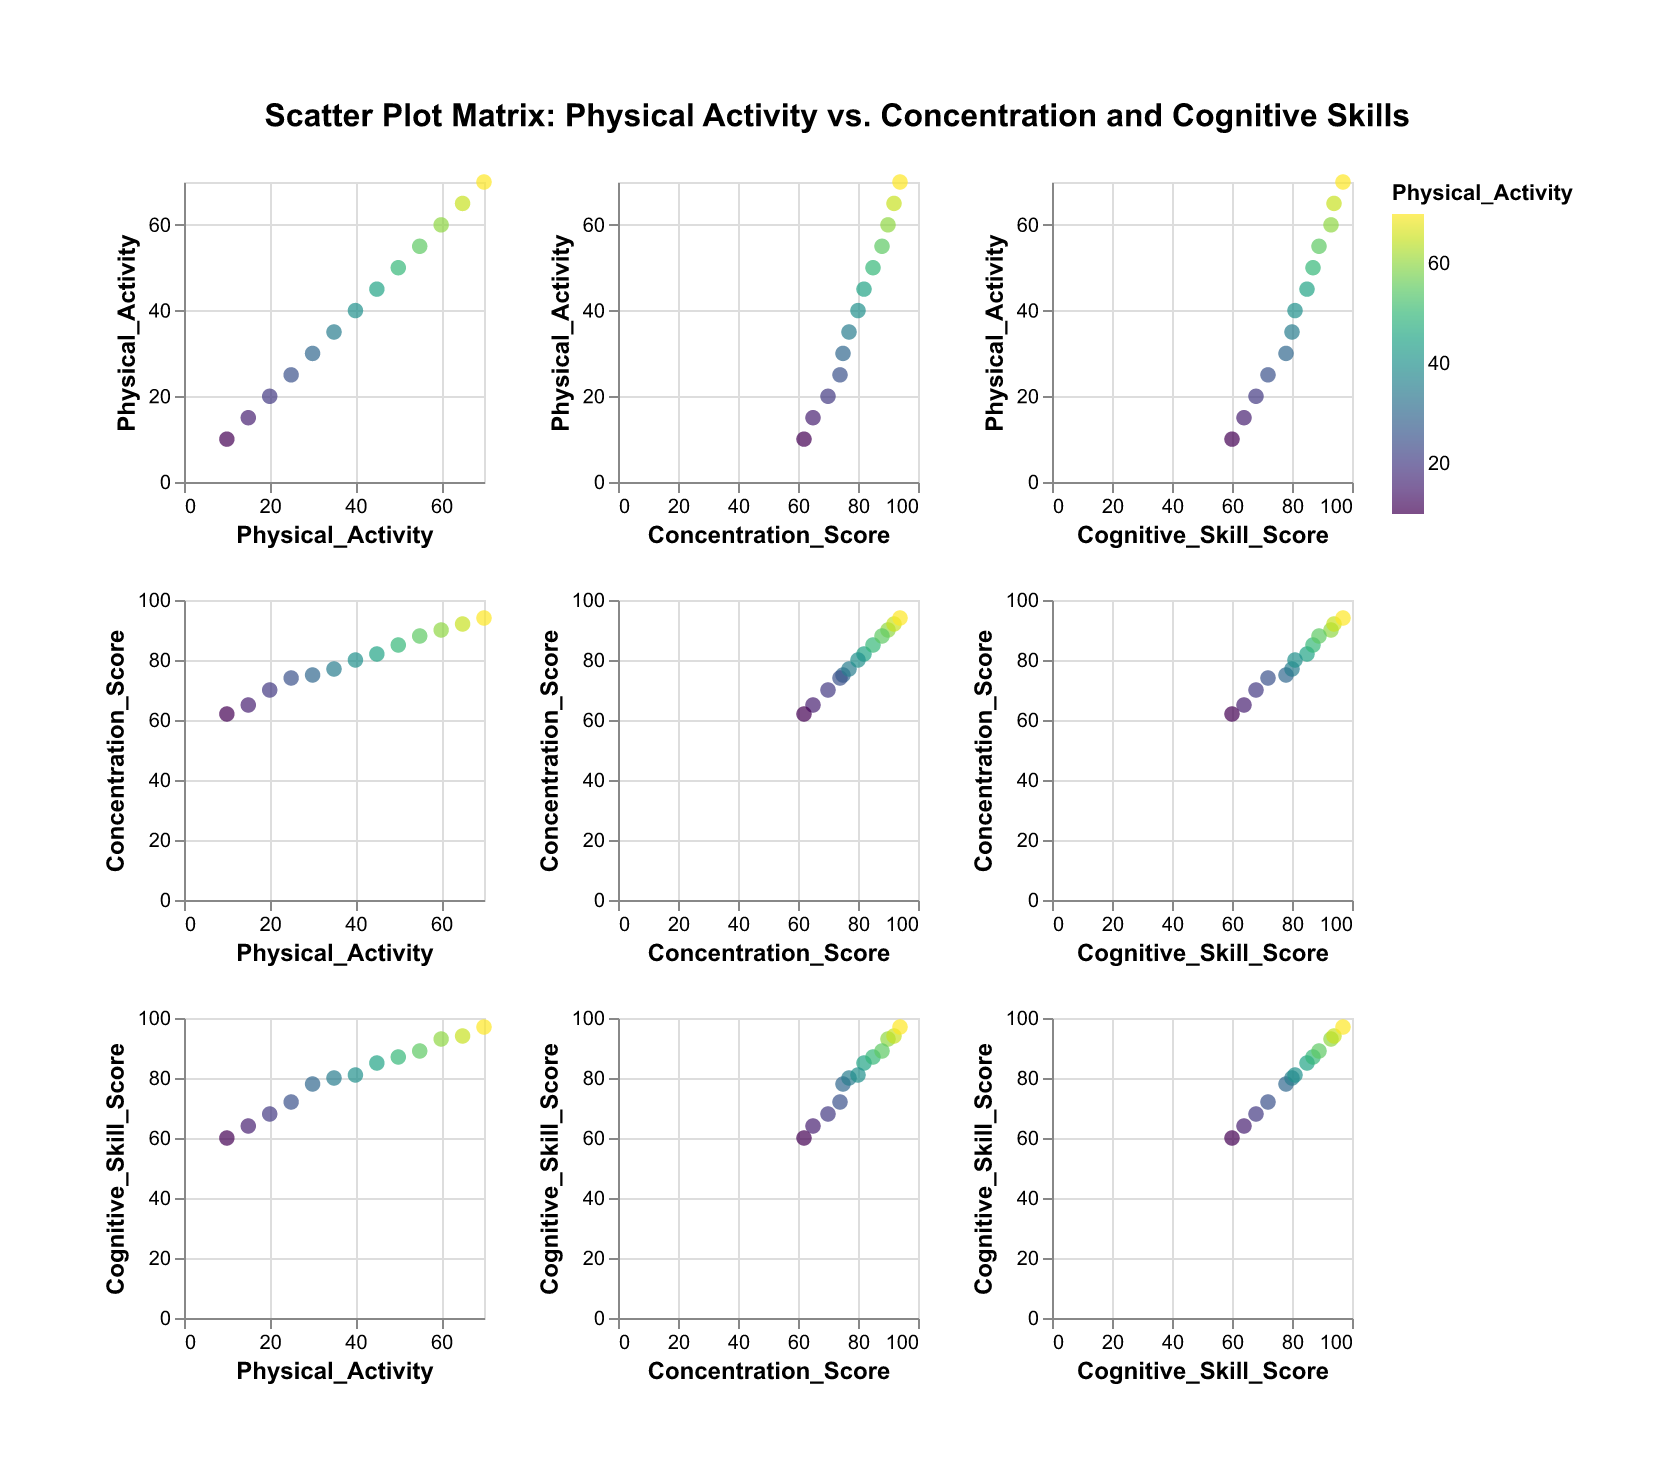What is the title of the scatter plot matrix? The title can be found at the top of the figure, usually indicating what the plot matrix is about. Here it is clearly stated.
Answer: Scatter Plot Matrix: Physical Activity vs. Concentration and Cognitive Skills How many data points are in the plot? Count the number of unique points on any of the scatter plots in the matrix. There are consistently 13 points across the plots.
Answer: 13 Which variable uses the color scheme? The color scheme is used to represent the 'Physical Activity' variable, as indicated in the legend inside the color scale.
Answer: Physical Activity What is the maximum value of the Cognitive Skill Score? Check the scatter plot column for 'Cognitive Skill Score' and look for the highest value on the y-axis or individual points.
Answer: 97 What is the range of Concentration Score values? The range is determined by the minimum and maximum values found on the y-axis for 'Concentration Score' scatter plots.
Answer: 62 to 94 Which scatter plot shows the relationship between Concentration Score and Physical Activity? Find the intersection of the rows and columns labeled 'Concentration Score' and 'Physical Activity'.
Answer: <Concentration Score, Physical Activity> Does a higher Physical Activity seem to correspond with higher Concentration Scores? Observe any upward trend in the scatter plot for Concentration Score vs. Physical Activity. Higher density of points appear at higher Concentration Scores with increasing Physical Activity.
Answer: Yes How does the relationship between Concentration Score and Cognitive Skill Score look? An upward trend in the scatter plot between Concentration Score and Cognitive Skill Score indicates a positive correlation.
Answer: Positive correlation If a person has a Physical Activity of 55, what is their likely Concentration Score range? Locate the points corresponding to a Physical Activity of 55 and see their positioning on the Concentration Score axis. It is around the value 88.
Answer: About 88 What is the median Physical Activity value? List all the Physical Activity values, sort them, and find the middle value in the ordered list. The median here is the 7th value in the sorted sequence (10, 15, 20, 25, 30, 35, 40, 45, 50, 55, 60, 65, 70).
Answer: 40 